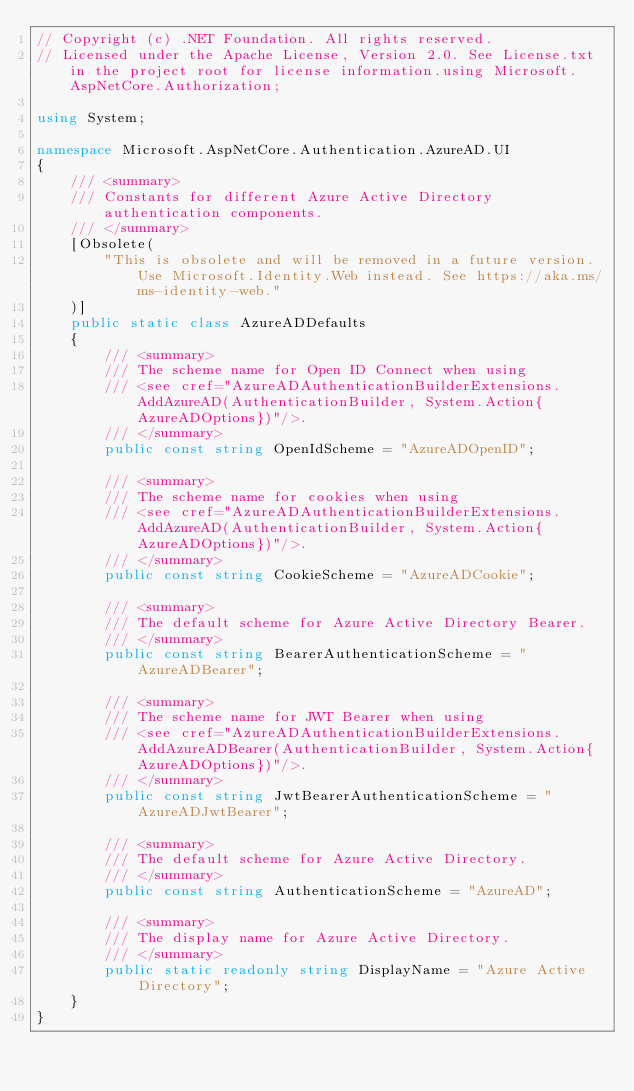Convert code to text. <code><loc_0><loc_0><loc_500><loc_500><_C#_>// Copyright (c) .NET Foundation. All rights reserved.
// Licensed under the Apache License, Version 2.0. See License.txt in the project root for license information.using Microsoft.AspNetCore.Authorization;

using System;

namespace Microsoft.AspNetCore.Authentication.AzureAD.UI
{
    /// <summary>
    /// Constants for different Azure Active Directory authentication components.
    /// </summary>
    [Obsolete(
        "This is obsolete and will be removed in a future version. Use Microsoft.Identity.Web instead. See https://aka.ms/ms-identity-web."
    )]
    public static class AzureADDefaults
    {
        /// <summary>
        /// The scheme name for Open ID Connect when using
        /// <see cref="AzureADAuthenticationBuilderExtensions.AddAzureAD(AuthenticationBuilder, System.Action{AzureADOptions})"/>.
        /// </summary>
        public const string OpenIdScheme = "AzureADOpenID";

        /// <summary>
        /// The scheme name for cookies when using
        /// <see cref="AzureADAuthenticationBuilderExtensions.AddAzureAD(AuthenticationBuilder, System.Action{AzureADOptions})"/>.
        /// </summary>
        public const string CookieScheme = "AzureADCookie";

        /// <summary>
        /// The default scheme for Azure Active Directory Bearer.
        /// </summary>
        public const string BearerAuthenticationScheme = "AzureADBearer";

        /// <summary>
        /// The scheme name for JWT Bearer when using
        /// <see cref="AzureADAuthenticationBuilderExtensions.AddAzureADBearer(AuthenticationBuilder, System.Action{AzureADOptions})"/>.
        /// </summary>
        public const string JwtBearerAuthenticationScheme = "AzureADJwtBearer";

        /// <summary>
        /// The default scheme for Azure Active Directory.
        /// </summary>
        public const string AuthenticationScheme = "AzureAD";

        /// <summary>
        /// The display name for Azure Active Directory.
        /// </summary>
        public static readonly string DisplayName = "Azure Active Directory";
    }
}
</code> 